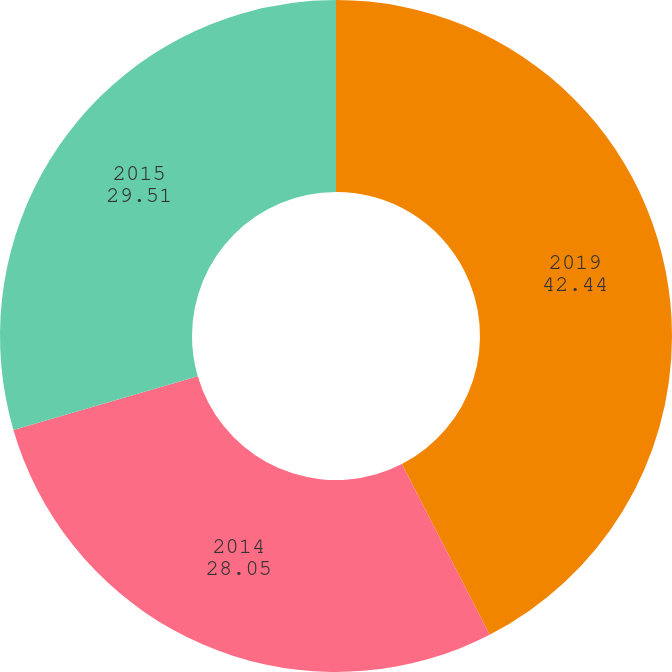<chart> <loc_0><loc_0><loc_500><loc_500><pie_chart><fcel>2019<fcel>2014<fcel>2015<nl><fcel>42.44%<fcel>28.05%<fcel>29.51%<nl></chart> 